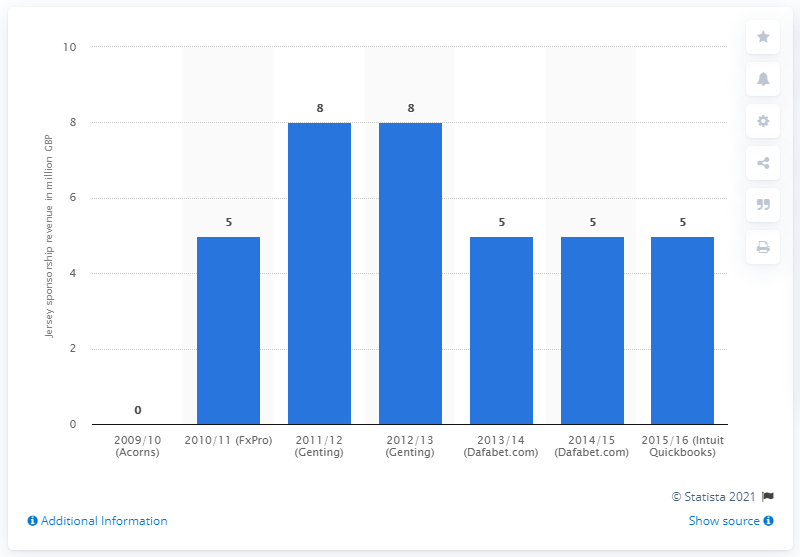Point out several critical features in this image. In the 2012/13 season, Aston Villa received a total of 8 million GBP from Genting. 